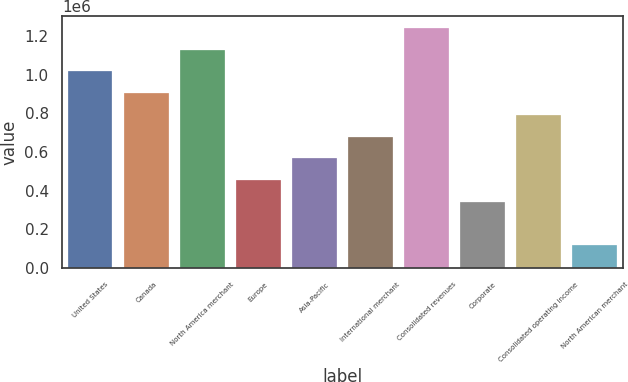<chart> <loc_0><loc_0><loc_500><loc_500><bar_chart><fcel>United States<fcel>Canada<fcel>North America merchant<fcel>Europe<fcel>Asia-Pacific<fcel>International merchant<fcel>Consolidated revenues<fcel>Corporate<fcel>Consolidated operating income<fcel>North American merchant<nl><fcel>1.01807e+06<fcel>905525<fcel>1.13061e+06<fcel>455358<fcel>567900<fcel>680442<fcel>1.24315e+06<fcel>342817<fcel>792983<fcel>117734<nl></chart> 